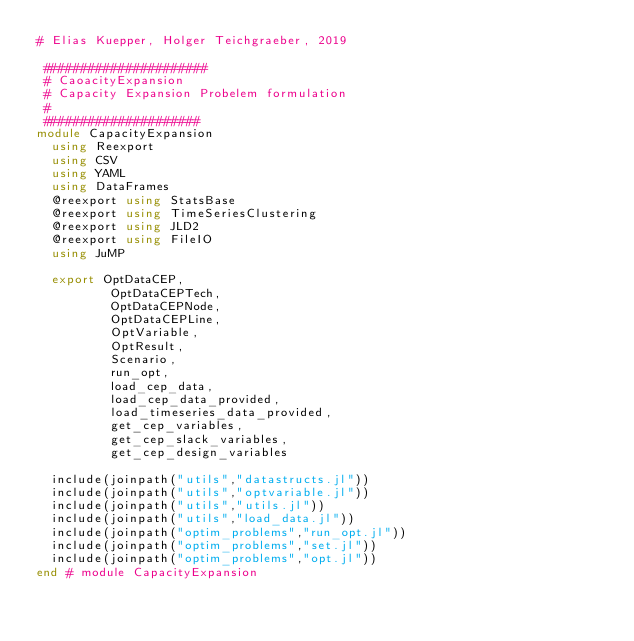<code> <loc_0><loc_0><loc_500><loc_500><_Julia_># Elias Kuepper, Holger Teichgraeber, 2019

 ######################
 # CaoacityExpansion
 # Capacity Expansion Probelem formulation
 #
 #####################
module CapacityExpansion
  using Reexport
  using CSV
  using YAML
  using DataFrames
  @reexport using StatsBase
  @reexport using TimeSeriesClustering
  @reexport using JLD2
  @reexport using FileIO
  using JuMP

  export OptDataCEP,
          OptDataCEPTech,
          OptDataCEPNode,
          OptDataCEPLine,
          OptVariable,
          OptResult,
          Scenario,
          run_opt,
          load_cep_data,
          load_cep_data_provided,
          load_timeseries_data_provided,
          get_cep_variables,
          get_cep_slack_variables,
          get_cep_design_variables

  include(joinpath("utils","datastructs.jl"))
  include(joinpath("utils","optvariable.jl"))
  include(joinpath("utils","utils.jl"))
  include(joinpath("utils","load_data.jl"))
  include(joinpath("optim_problems","run_opt.jl"))
  include(joinpath("optim_problems","set.jl"))
  include(joinpath("optim_problems","opt.jl"))
end # module CapacityExpansion
</code> 